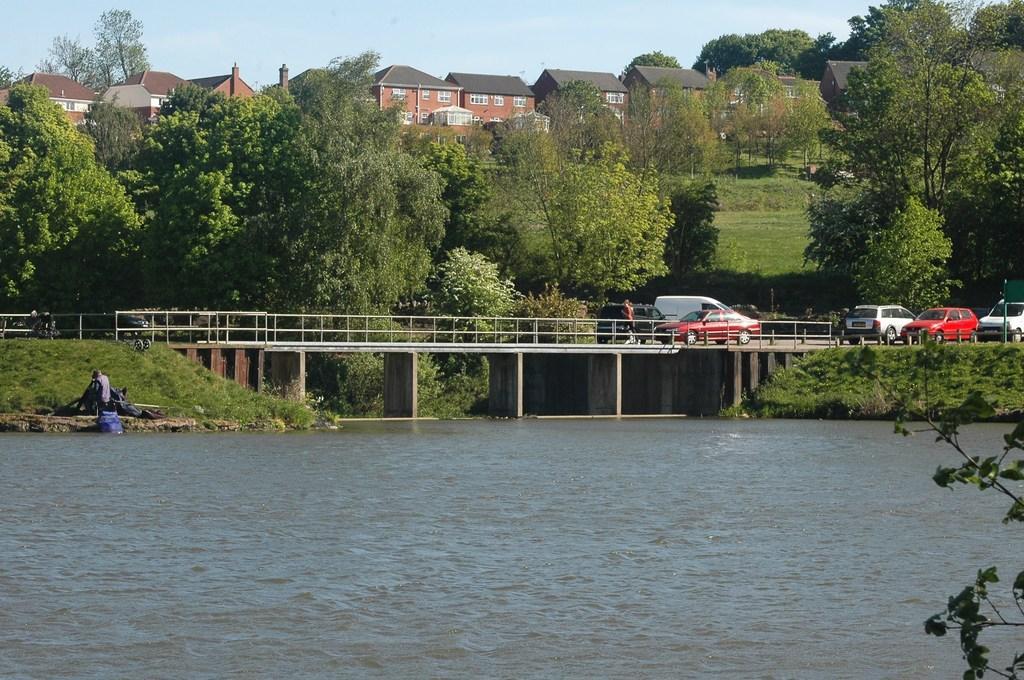Could you give a brief overview of what you see in this image? In this picture we can see vehicles on the bridge surrounded by trees and houses. There is a river under the bridge surrounded by grass and rocks. The sky is blue. 